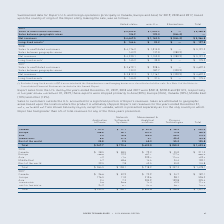From Roper Technologies's financial document, What are the proportions of export sales from the U.S. to Asia and Europe, respectively?  The document shows two values: 33% and 24%. From the document: "rts were shipped primarily to Asia (33%), Europe (24%), Canada (18%), Middle East (13%) and other (12%). 19, these exports were shipped primarily to A..." Also, What is the total net revenue from Canada in 2019? According to the financial document, $ 222.4. The relevant text states: "2019 Canada $ 41.0 $ 71.1 $ 81.4 $ 28.9 $ 222.4..." Also, What is the total net revenue from the rest of the world in 2017? According to the financial document, 120.0. The relevant text states: "Rest of the world 23.2 6.1 42.0 48.7 120.0..." Also, can you calculate: What is the percentage change in net revenue from the Middle East in 2019 compared to 2018? To answer this question, I need to perform calculations using the financial data. The calculation is: (103.6-102.1)/102.1 , which equals 1.47 (percentage). This is based on the information: "Middle East 8.6 37.5 13.1 44.4 103.6 Middle East 4.7 48.6 14.4 34.4 102.1..." The key data points involved are: 102.1, 103.6. Also, can you calculate: What is the proportion of net revenue from Europe and Asia over total net revenue in 2017? To answer this question, I need to perform calculations using the financial data. The calculation is: (596.2 +325.4)/1,341.2 , which equals 0.69. This is based on the information: "Europe 176.5 11.0 310.6 98.1 596.2 Total $ 233.5 $ 136.1 $ 644.8 $ 326.8 $ 1,341.2 Asia 2.4 7.3 205.9 109.8 325.4..." The key data points involved are: 1,341.2, 325.4, 596.2. Also, can you calculate: What is the ratio of net revenue from the Application Software segment to the Process Technologies segment in 2018? Based on the calculation: 264.5/357.3 , the result is 0.74. This is based on the information: "Total $ 264.5 $ 138.1 $ 718.2 $ 357.3 $ 1,478.1 Total $ 264.5 $ 138.1 $ 718.2 $ 357.3 $ 1,478.1..." The key data points involved are: 264.5, 357.3. 